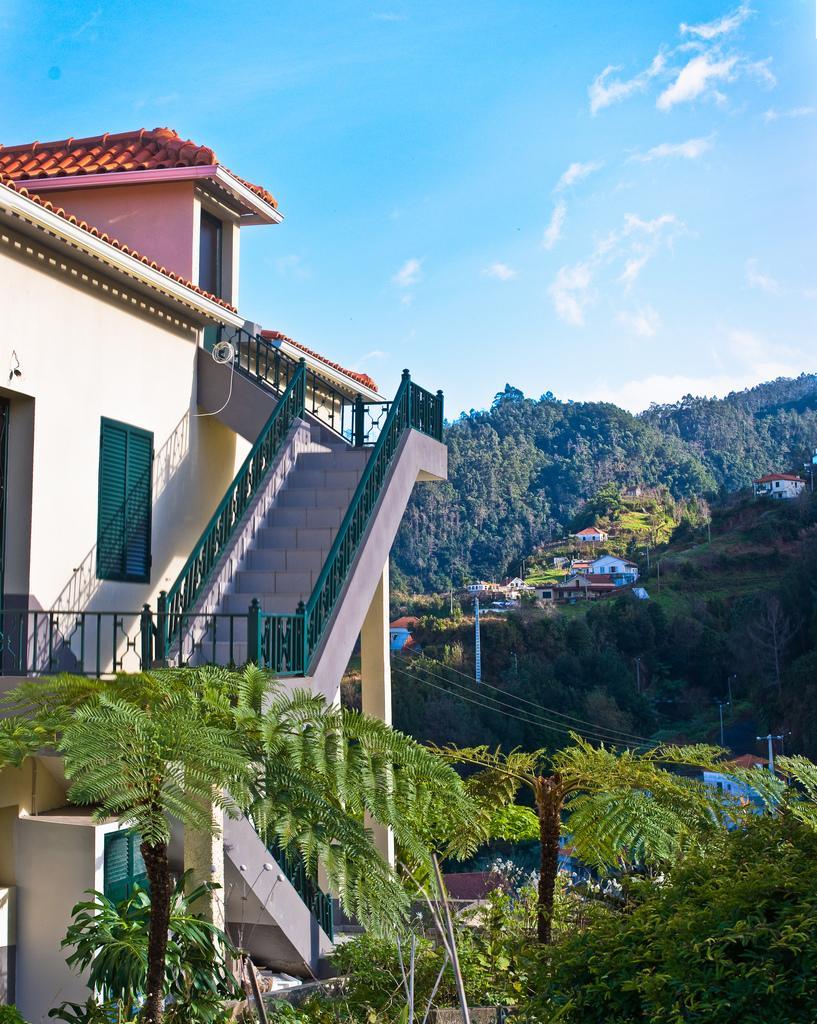Describe this image in one or two sentences. In this picture we can see trees, buildings, steps, windows, poles, wires, mountains and in the background we can see the sky with clouds. 